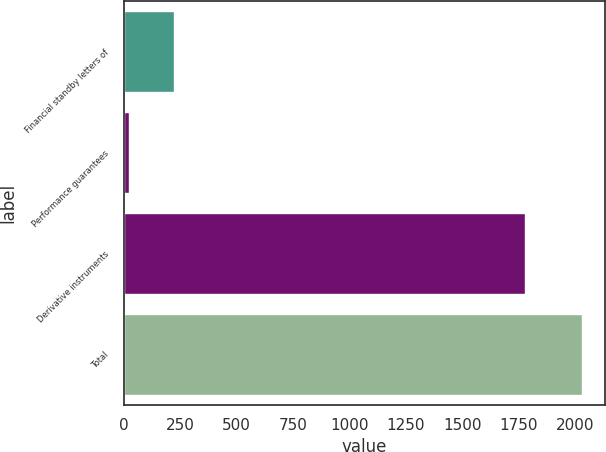<chart> <loc_0><loc_0><loc_500><loc_500><bar_chart><fcel>Financial standby letters of<fcel>Performance guarantees<fcel>Derivative instruments<fcel>Total<nl><fcel>224.5<fcel>24<fcel>1779<fcel>2029<nl></chart> 